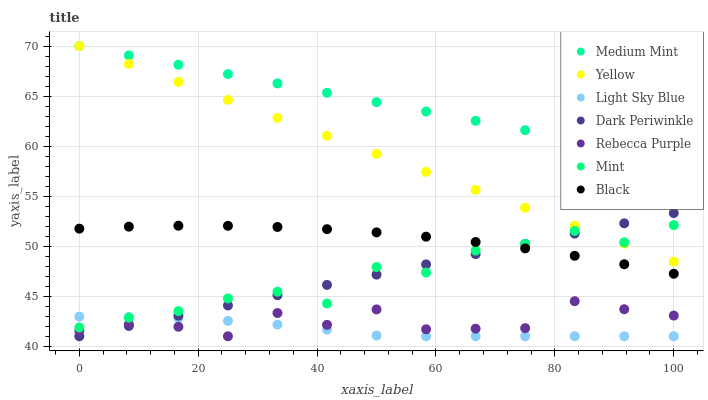Does Light Sky Blue have the minimum area under the curve?
Answer yes or no. Yes. Does Medium Mint have the maximum area under the curve?
Answer yes or no. Yes. Does Yellow have the minimum area under the curve?
Answer yes or no. No. Does Yellow have the maximum area under the curve?
Answer yes or no. No. Is Yellow the smoothest?
Answer yes or no. Yes. Is Rebecca Purple the roughest?
Answer yes or no. Yes. Is Light Sky Blue the smoothest?
Answer yes or no. No. Is Light Sky Blue the roughest?
Answer yes or no. No. Does Light Sky Blue have the lowest value?
Answer yes or no. Yes. Does Yellow have the lowest value?
Answer yes or no. No. Does Yellow have the highest value?
Answer yes or no. Yes. Does Light Sky Blue have the highest value?
Answer yes or no. No. Is Light Sky Blue less than Medium Mint?
Answer yes or no. Yes. Is Medium Mint greater than Light Sky Blue?
Answer yes or no. Yes. Does Yellow intersect Medium Mint?
Answer yes or no. Yes. Is Yellow less than Medium Mint?
Answer yes or no. No. Is Yellow greater than Medium Mint?
Answer yes or no. No. Does Light Sky Blue intersect Medium Mint?
Answer yes or no. No. 